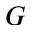Convert formula to latex. <formula><loc_0><loc_0><loc_500><loc_500>G</formula> 